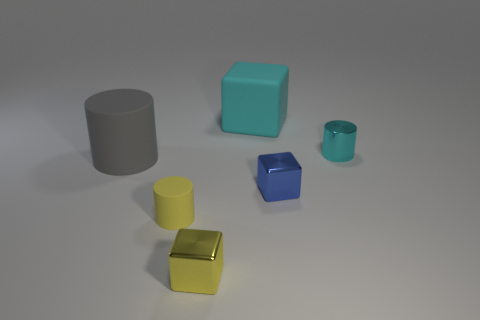What number of gray objects are tiny cubes or metallic objects?
Give a very brief answer. 0. What shape is the tiny metallic thing that is on the left side of the big thing that is behind the tiny cyan metal object?
Your answer should be compact. Cube. There is a yellow metal object that is the same size as the yellow matte cylinder; what shape is it?
Provide a succinct answer. Cube. Are there any large things that have the same color as the metal cylinder?
Keep it short and to the point. Yes. Are there the same number of matte cylinders that are behind the big matte cylinder and yellow matte cylinders that are behind the metallic cylinder?
Your answer should be very brief. Yes. There is a small blue metal thing; is it the same shape as the big thing behind the tiny cyan metallic cylinder?
Your response must be concise. Yes. How many other things are made of the same material as the blue object?
Ensure brevity in your answer.  2. Are there any small yellow metal blocks behind the big cyan thing?
Your answer should be compact. No. There is a blue block; is its size the same as the block behind the big cylinder?
Your answer should be compact. No. What color is the large object in front of the big thing behind the big cylinder?
Offer a terse response. Gray. 